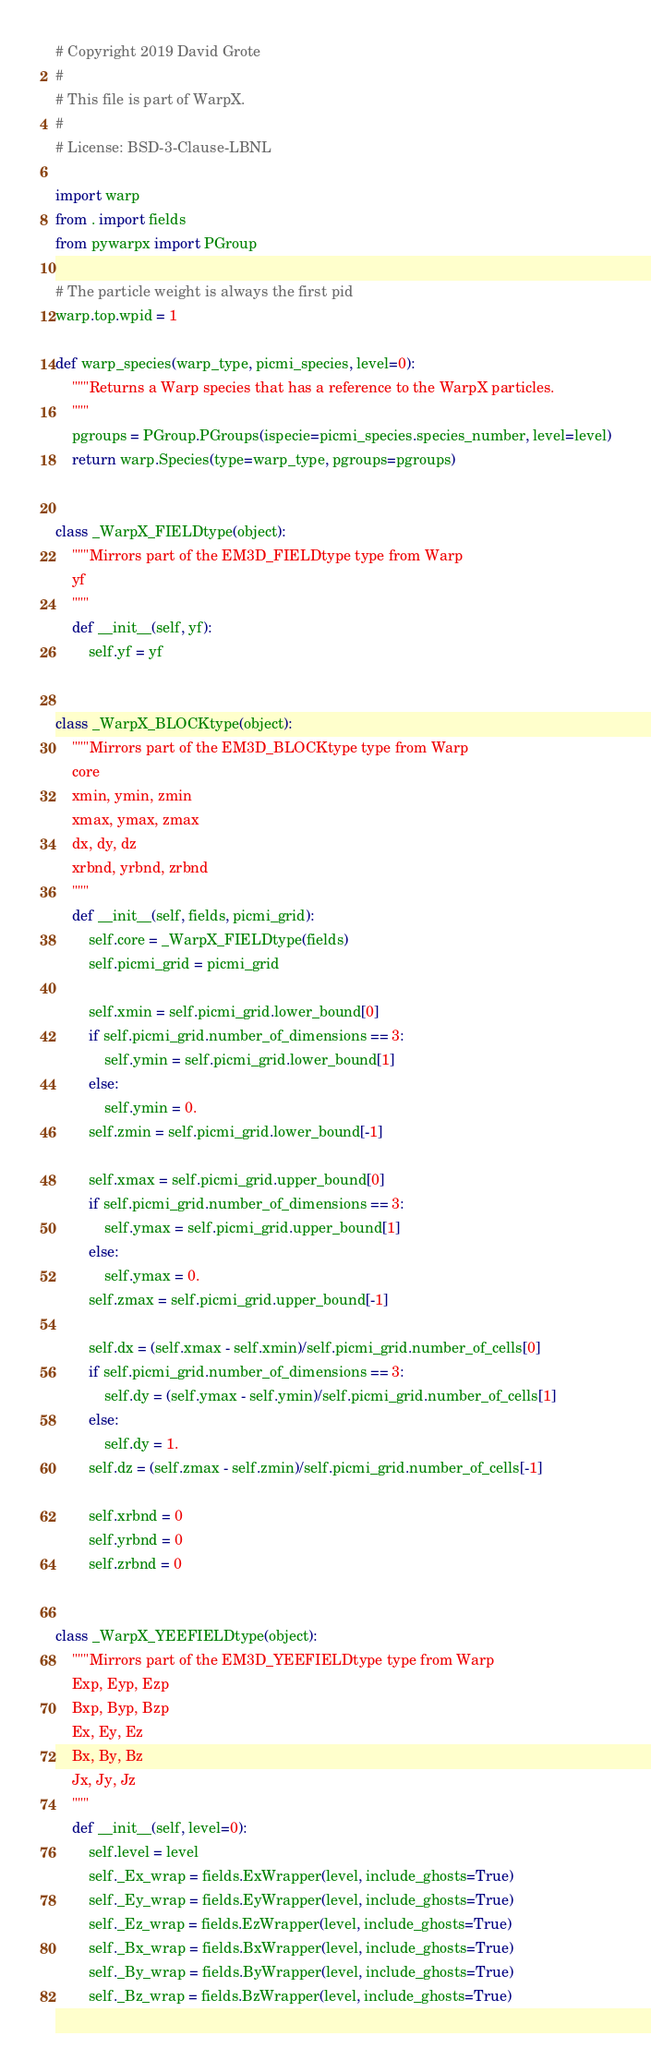<code> <loc_0><loc_0><loc_500><loc_500><_Python_># Copyright 2019 David Grote
#
# This file is part of WarpX.
#
# License: BSD-3-Clause-LBNL

import warp
from . import fields
from pywarpx import PGroup

# The particle weight is always the first pid
warp.top.wpid = 1

def warp_species(warp_type, picmi_species, level=0):
    """Returns a Warp species that has a reference to the WarpX particles.
    """
    pgroups = PGroup.PGroups(ispecie=picmi_species.species_number, level=level)
    return warp.Species(type=warp_type, pgroups=pgroups)


class _WarpX_FIELDtype(object):
    """Mirrors part of the EM3D_FIELDtype type from Warp
    yf
    """
    def __init__(self, yf):
        self.yf = yf


class _WarpX_BLOCKtype(object):
    """Mirrors part of the EM3D_BLOCKtype type from Warp
    core
    xmin, ymin, zmin
    xmax, ymax, zmax
    dx, dy, dz
    xrbnd, yrbnd, zrbnd
    """
    def __init__(self, fields, picmi_grid):
        self.core = _WarpX_FIELDtype(fields)
        self.picmi_grid = picmi_grid

        self.xmin = self.picmi_grid.lower_bound[0]
        if self.picmi_grid.number_of_dimensions == 3:
            self.ymin = self.picmi_grid.lower_bound[1]
        else:
            self.ymin = 0.
        self.zmin = self.picmi_grid.lower_bound[-1]

        self.xmax = self.picmi_grid.upper_bound[0]
        if self.picmi_grid.number_of_dimensions == 3:
            self.ymax = self.picmi_grid.upper_bound[1]
        else:
            self.ymax = 0.
        self.zmax = self.picmi_grid.upper_bound[-1]

        self.dx = (self.xmax - self.xmin)/self.picmi_grid.number_of_cells[0]
        if self.picmi_grid.number_of_dimensions == 3:
            self.dy = (self.ymax - self.ymin)/self.picmi_grid.number_of_cells[1]
        else:
            self.dy = 1.
        self.dz = (self.zmax - self.zmin)/self.picmi_grid.number_of_cells[-1]

        self.xrbnd = 0
        self.yrbnd = 0
        self.zrbnd = 0


class _WarpX_YEEFIELDtype(object):
    """Mirrors part of the EM3D_YEEFIELDtype type from Warp
    Exp, Eyp, Ezp
    Bxp, Byp, Bzp
    Ex, Ey, Ez
    Bx, By, Bz
    Jx, Jy, Jz
    """
    def __init__(self, level=0):
        self.level = level
        self._Ex_wrap = fields.ExWrapper(level, include_ghosts=True)
        self._Ey_wrap = fields.EyWrapper(level, include_ghosts=True)
        self._Ez_wrap = fields.EzWrapper(level, include_ghosts=True)
        self._Bx_wrap = fields.BxWrapper(level, include_ghosts=True)
        self._By_wrap = fields.ByWrapper(level, include_ghosts=True)
        self._Bz_wrap = fields.BzWrapper(level, include_ghosts=True)</code> 